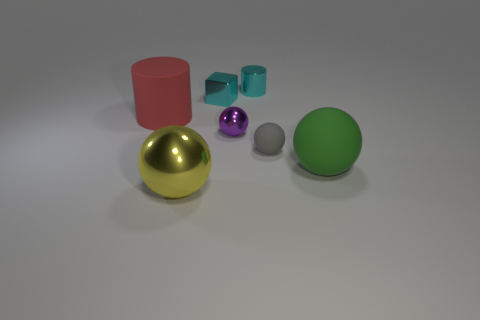There is a gray matte ball; are there any rubber cylinders in front of it?
Provide a succinct answer. No. Is the color of the small block the same as the metallic cylinder?
Your answer should be very brief. Yes. How many tiny metal cylinders have the same color as the metal cube?
Offer a terse response. 1. There is a metallic ball that is right of the tiny cyan object that is in front of the metallic cylinder; what size is it?
Provide a succinct answer. Small. There is a yellow metal thing; what shape is it?
Make the answer very short. Sphere. What is the large sphere that is left of the tiny purple shiny sphere made of?
Your response must be concise. Metal. What is the color of the large rubber thing that is behind the large ball that is on the right side of the tiny gray rubber sphere that is in front of the matte cylinder?
Your response must be concise. Red. There is a matte ball that is the same size as the cyan shiny cylinder; what color is it?
Give a very brief answer. Gray. What number of shiny objects are large green balls or balls?
Provide a succinct answer. 2. The tiny object that is made of the same material as the big cylinder is what color?
Your answer should be very brief. Gray. 